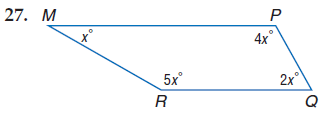Question: Find m \angle M.
Choices:
A. 30
B. 60
C. 120
D. 150
Answer with the letter. Answer: A Question: Find m \angle R.
Choices:
A. 30
B. 60
C. 120
D. 150
Answer with the letter. Answer: D Question: Find m \angle Q.
Choices:
A. 30
B. 60
C. 120
D. 150
Answer with the letter. Answer: B Question: Find m \angle P.
Choices:
A. 30
B. 60
C. 120
D. 150
Answer with the letter. Answer: C 